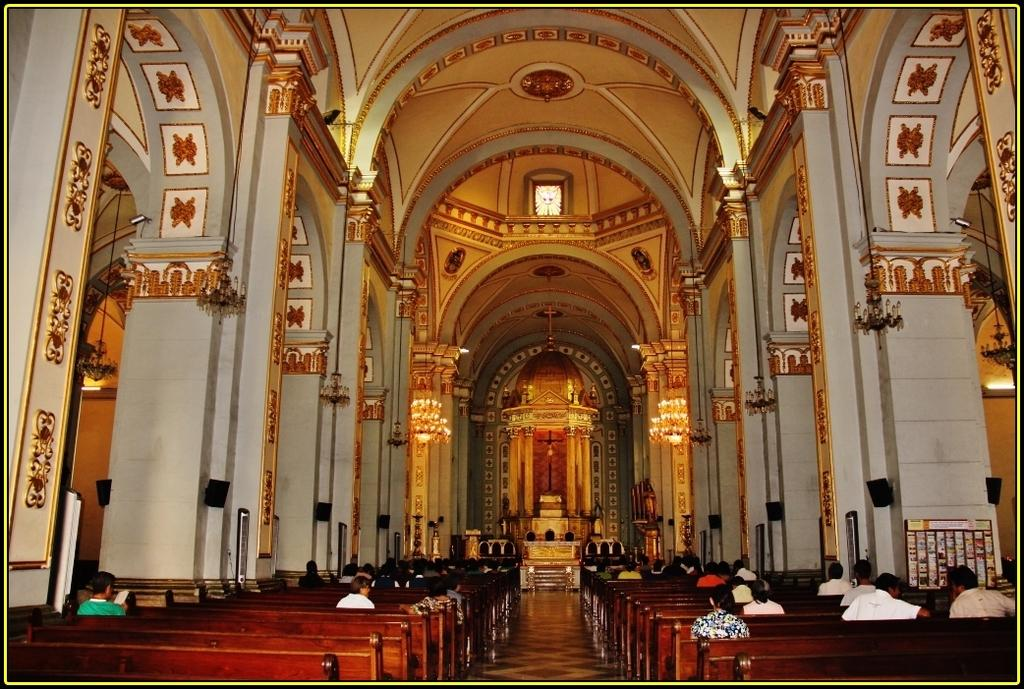Where was the image taken? The image was taken inside a church. What are the people in the image doing? The people in the image are sitting on benches. What architectural features can be seen in the image? There are pillars visible in the image. What religious symbol can be seen in the background of the image? There is a crucifix in the background of the image. Where can you find a basket full of books in the image? There is no basket full of books present in the image. 